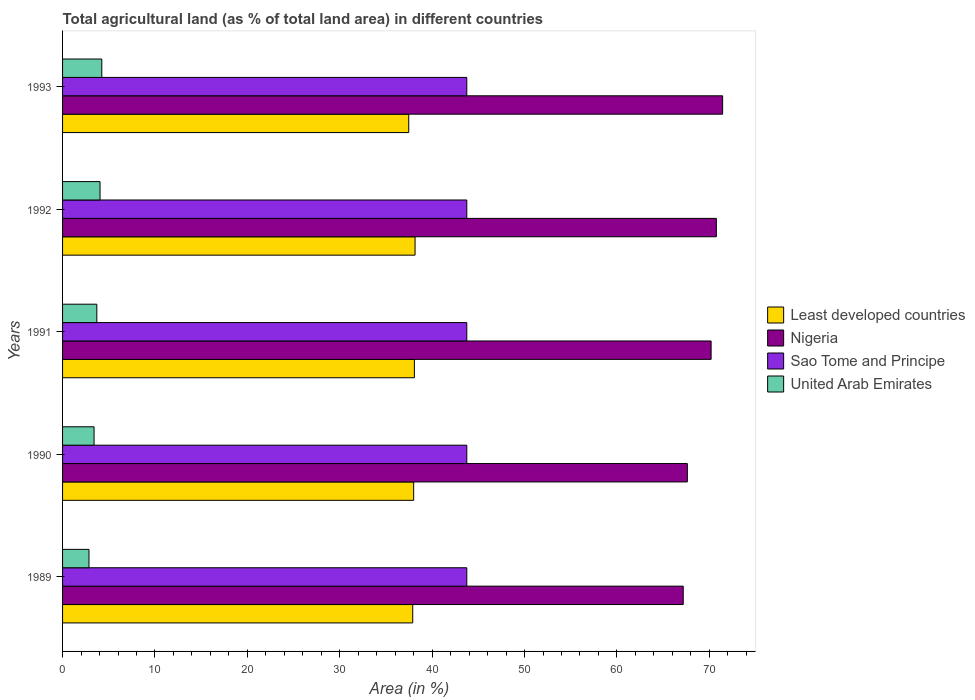Are the number of bars per tick equal to the number of legend labels?
Offer a very short reply. Yes. Are the number of bars on each tick of the Y-axis equal?
Your answer should be compact. Yes. How many bars are there on the 3rd tick from the top?
Offer a terse response. 4. How many bars are there on the 5th tick from the bottom?
Your answer should be compact. 4. What is the percentage of agricultural land in United Arab Emirates in 1991?
Make the answer very short. 3.71. Across all years, what is the maximum percentage of agricultural land in Least developed countries?
Provide a short and direct response. 38.15. Across all years, what is the minimum percentage of agricultural land in Least developed countries?
Offer a very short reply. 37.47. In which year was the percentage of agricultural land in United Arab Emirates minimum?
Make the answer very short. 1989. What is the total percentage of agricultural land in United Arab Emirates in the graph?
Offer a very short reply. 18.28. What is the difference between the percentage of agricultural land in Nigeria in 1990 and that in 1993?
Offer a terse response. -3.82. What is the difference between the percentage of agricultural land in Least developed countries in 1990 and the percentage of agricultural land in Nigeria in 1989?
Give a very brief answer. -29.18. What is the average percentage of agricultural land in Least developed countries per year?
Keep it short and to the point. 37.92. In the year 1991, what is the difference between the percentage of agricultural land in Sao Tome and Principe and percentage of agricultural land in Nigeria?
Offer a very short reply. -26.44. What is the ratio of the percentage of agricultural land in Sao Tome and Principe in 1989 to that in 1991?
Ensure brevity in your answer.  1. Is the percentage of agricultural land in Least developed countries in 1990 less than that in 1991?
Your response must be concise. Yes. Is the difference between the percentage of agricultural land in Sao Tome and Principe in 1990 and 1993 greater than the difference between the percentage of agricultural land in Nigeria in 1990 and 1993?
Provide a short and direct response. Yes. What is the difference between the highest and the second highest percentage of agricultural land in United Arab Emirates?
Ensure brevity in your answer.  0.19. What is the difference between the highest and the lowest percentage of agricultural land in United Arab Emirates?
Ensure brevity in your answer.  1.39. Is it the case that in every year, the sum of the percentage of agricultural land in Nigeria and percentage of agricultural land in Least developed countries is greater than the sum of percentage of agricultural land in United Arab Emirates and percentage of agricultural land in Sao Tome and Principe?
Make the answer very short. No. What does the 4th bar from the top in 1989 represents?
Offer a terse response. Least developed countries. What does the 1st bar from the bottom in 1992 represents?
Offer a terse response. Least developed countries. Is it the case that in every year, the sum of the percentage of agricultural land in Sao Tome and Principe and percentage of agricultural land in Least developed countries is greater than the percentage of agricultural land in Nigeria?
Provide a succinct answer. Yes. Are all the bars in the graph horizontal?
Provide a succinct answer. Yes. How many years are there in the graph?
Make the answer very short. 5. What is the difference between two consecutive major ticks on the X-axis?
Your response must be concise. 10. Does the graph contain any zero values?
Ensure brevity in your answer.  No. Where does the legend appear in the graph?
Your answer should be compact. Center right. How many legend labels are there?
Give a very brief answer. 4. What is the title of the graph?
Offer a terse response. Total agricultural land (as % of total land area) in different countries. What is the label or title of the X-axis?
Offer a very short reply. Area (in %). What is the label or title of the Y-axis?
Keep it short and to the point. Years. What is the Area (in %) of Least developed countries in 1989?
Your answer should be compact. 37.9. What is the Area (in %) of Nigeria in 1989?
Your answer should be very brief. 67.18. What is the Area (in %) in Sao Tome and Principe in 1989?
Ensure brevity in your answer.  43.75. What is the Area (in %) in United Arab Emirates in 1989?
Make the answer very short. 2.86. What is the Area (in %) of Least developed countries in 1990?
Make the answer very short. 38. What is the Area (in %) of Nigeria in 1990?
Your answer should be very brief. 67.62. What is the Area (in %) of Sao Tome and Principe in 1990?
Keep it short and to the point. 43.75. What is the Area (in %) of United Arab Emirates in 1990?
Ensure brevity in your answer.  3.41. What is the Area (in %) in Least developed countries in 1991?
Your answer should be compact. 38.08. What is the Area (in %) of Nigeria in 1991?
Your answer should be compact. 70.19. What is the Area (in %) in Sao Tome and Principe in 1991?
Provide a short and direct response. 43.75. What is the Area (in %) of United Arab Emirates in 1991?
Offer a terse response. 3.71. What is the Area (in %) in Least developed countries in 1992?
Ensure brevity in your answer.  38.15. What is the Area (in %) of Nigeria in 1992?
Give a very brief answer. 70.76. What is the Area (in %) in Sao Tome and Principe in 1992?
Give a very brief answer. 43.75. What is the Area (in %) of United Arab Emirates in 1992?
Your answer should be compact. 4.06. What is the Area (in %) in Least developed countries in 1993?
Offer a terse response. 37.47. What is the Area (in %) of Nigeria in 1993?
Your answer should be compact. 71.44. What is the Area (in %) of Sao Tome and Principe in 1993?
Your answer should be compact. 43.75. What is the Area (in %) of United Arab Emirates in 1993?
Provide a short and direct response. 4.25. Across all years, what is the maximum Area (in %) of Least developed countries?
Provide a succinct answer. 38.15. Across all years, what is the maximum Area (in %) of Nigeria?
Offer a terse response. 71.44. Across all years, what is the maximum Area (in %) in Sao Tome and Principe?
Ensure brevity in your answer.  43.75. Across all years, what is the maximum Area (in %) of United Arab Emirates?
Ensure brevity in your answer.  4.25. Across all years, what is the minimum Area (in %) in Least developed countries?
Give a very brief answer. 37.47. Across all years, what is the minimum Area (in %) of Nigeria?
Provide a succinct answer. 67.18. Across all years, what is the minimum Area (in %) in Sao Tome and Principe?
Offer a terse response. 43.75. Across all years, what is the minimum Area (in %) of United Arab Emirates?
Make the answer very short. 2.86. What is the total Area (in %) in Least developed countries in the graph?
Give a very brief answer. 189.59. What is the total Area (in %) of Nigeria in the graph?
Give a very brief answer. 347.19. What is the total Area (in %) in Sao Tome and Principe in the graph?
Ensure brevity in your answer.  218.75. What is the total Area (in %) of United Arab Emirates in the graph?
Make the answer very short. 18.28. What is the difference between the Area (in %) in Least developed countries in 1989 and that in 1990?
Offer a terse response. -0.1. What is the difference between the Area (in %) in Nigeria in 1989 and that in 1990?
Keep it short and to the point. -0.44. What is the difference between the Area (in %) of Sao Tome and Principe in 1989 and that in 1990?
Keep it short and to the point. 0. What is the difference between the Area (in %) in United Arab Emirates in 1989 and that in 1990?
Keep it short and to the point. -0.55. What is the difference between the Area (in %) of Least developed countries in 1989 and that in 1991?
Keep it short and to the point. -0.18. What is the difference between the Area (in %) in Nigeria in 1989 and that in 1991?
Give a very brief answer. -3.02. What is the difference between the Area (in %) of Sao Tome and Principe in 1989 and that in 1991?
Your answer should be very brief. 0. What is the difference between the Area (in %) of United Arab Emirates in 1989 and that in 1991?
Offer a terse response. -0.85. What is the difference between the Area (in %) of Least developed countries in 1989 and that in 1992?
Offer a very short reply. -0.25. What is the difference between the Area (in %) in Nigeria in 1989 and that in 1992?
Ensure brevity in your answer.  -3.58. What is the difference between the Area (in %) in United Arab Emirates in 1989 and that in 1992?
Provide a succinct answer. -1.2. What is the difference between the Area (in %) of Least developed countries in 1989 and that in 1993?
Provide a short and direct response. 0.43. What is the difference between the Area (in %) in Nigeria in 1989 and that in 1993?
Ensure brevity in your answer.  -4.26. What is the difference between the Area (in %) of Sao Tome and Principe in 1989 and that in 1993?
Your answer should be very brief. 0. What is the difference between the Area (in %) in United Arab Emirates in 1989 and that in 1993?
Offer a terse response. -1.39. What is the difference between the Area (in %) of Least developed countries in 1990 and that in 1991?
Provide a succinct answer. -0.08. What is the difference between the Area (in %) of Nigeria in 1990 and that in 1991?
Ensure brevity in your answer.  -2.57. What is the difference between the Area (in %) of United Arab Emirates in 1990 and that in 1991?
Make the answer very short. -0.3. What is the difference between the Area (in %) of Least developed countries in 1990 and that in 1992?
Your answer should be compact. -0.15. What is the difference between the Area (in %) of Nigeria in 1990 and that in 1992?
Give a very brief answer. -3.14. What is the difference between the Area (in %) in Sao Tome and Principe in 1990 and that in 1992?
Provide a short and direct response. 0. What is the difference between the Area (in %) of United Arab Emirates in 1990 and that in 1992?
Make the answer very short. -0.65. What is the difference between the Area (in %) in Least developed countries in 1990 and that in 1993?
Ensure brevity in your answer.  0.53. What is the difference between the Area (in %) of Nigeria in 1990 and that in 1993?
Make the answer very short. -3.82. What is the difference between the Area (in %) of United Arab Emirates in 1990 and that in 1993?
Give a very brief answer. -0.84. What is the difference between the Area (in %) in Least developed countries in 1991 and that in 1992?
Keep it short and to the point. -0.07. What is the difference between the Area (in %) of Nigeria in 1991 and that in 1992?
Keep it short and to the point. -0.57. What is the difference between the Area (in %) in Sao Tome and Principe in 1991 and that in 1992?
Offer a very short reply. 0. What is the difference between the Area (in %) of United Arab Emirates in 1991 and that in 1992?
Ensure brevity in your answer.  -0.35. What is the difference between the Area (in %) in Least developed countries in 1991 and that in 1993?
Make the answer very short. 0.61. What is the difference between the Area (in %) in Nigeria in 1991 and that in 1993?
Ensure brevity in your answer.  -1.25. What is the difference between the Area (in %) of United Arab Emirates in 1991 and that in 1993?
Provide a succinct answer. -0.54. What is the difference between the Area (in %) in Least developed countries in 1992 and that in 1993?
Provide a succinct answer. 0.68. What is the difference between the Area (in %) of Nigeria in 1992 and that in 1993?
Your response must be concise. -0.68. What is the difference between the Area (in %) in Sao Tome and Principe in 1992 and that in 1993?
Offer a terse response. 0. What is the difference between the Area (in %) in United Arab Emirates in 1992 and that in 1993?
Offer a very short reply. -0.19. What is the difference between the Area (in %) in Least developed countries in 1989 and the Area (in %) in Nigeria in 1990?
Your answer should be very brief. -29.72. What is the difference between the Area (in %) in Least developed countries in 1989 and the Area (in %) in Sao Tome and Principe in 1990?
Your answer should be very brief. -5.85. What is the difference between the Area (in %) in Least developed countries in 1989 and the Area (in %) in United Arab Emirates in 1990?
Provide a short and direct response. 34.49. What is the difference between the Area (in %) of Nigeria in 1989 and the Area (in %) of Sao Tome and Principe in 1990?
Keep it short and to the point. 23.43. What is the difference between the Area (in %) of Nigeria in 1989 and the Area (in %) of United Arab Emirates in 1990?
Offer a terse response. 63.77. What is the difference between the Area (in %) in Sao Tome and Principe in 1989 and the Area (in %) in United Arab Emirates in 1990?
Your answer should be compact. 40.34. What is the difference between the Area (in %) of Least developed countries in 1989 and the Area (in %) of Nigeria in 1991?
Your response must be concise. -32.29. What is the difference between the Area (in %) in Least developed countries in 1989 and the Area (in %) in Sao Tome and Principe in 1991?
Offer a terse response. -5.85. What is the difference between the Area (in %) in Least developed countries in 1989 and the Area (in %) in United Arab Emirates in 1991?
Your answer should be very brief. 34.19. What is the difference between the Area (in %) in Nigeria in 1989 and the Area (in %) in Sao Tome and Principe in 1991?
Ensure brevity in your answer.  23.43. What is the difference between the Area (in %) in Nigeria in 1989 and the Area (in %) in United Arab Emirates in 1991?
Provide a short and direct response. 63.47. What is the difference between the Area (in %) in Sao Tome and Principe in 1989 and the Area (in %) in United Arab Emirates in 1991?
Offer a very short reply. 40.04. What is the difference between the Area (in %) of Least developed countries in 1989 and the Area (in %) of Nigeria in 1992?
Offer a very short reply. -32.86. What is the difference between the Area (in %) in Least developed countries in 1989 and the Area (in %) in Sao Tome and Principe in 1992?
Ensure brevity in your answer.  -5.85. What is the difference between the Area (in %) in Least developed countries in 1989 and the Area (in %) in United Arab Emirates in 1992?
Ensure brevity in your answer.  33.84. What is the difference between the Area (in %) of Nigeria in 1989 and the Area (in %) of Sao Tome and Principe in 1992?
Ensure brevity in your answer.  23.43. What is the difference between the Area (in %) of Nigeria in 1989 and the Area (in %) of United Arab Emirates in 1992?
Provide a short and direct response. 63.12. What is the difference between the Area (in %) in Sao Tome and Principe in 1989 and the Area (in %) in United Arab Emirates in 1992?
Provide a short and direct response. 39.7. What is the difference between the Area (in %) in Least developed countries in 1989 and the Area (in %) in Nigeria in 1993?
Offer a terse response. -33.54. What is the difference between the Area (in %) of Least developed countries in 1989 and the Area (in %) of Sao Tome and Principe in 1993?
Your response must be concise. -5.85. What is the difference between the Area (in %) of Least developed countries in 1989 and the Area (in %) of United Arab Emirates in 1993?
Your answer should be compact. 33.65. What is the difference between the Area (in %) of Nigeria in 1989 and the Area (in %) of Sao Tome and Principe in 1993?
Keep it short and to the point. 23.43. What is the difference between the Area (in %) in Nigeria in 1989 and the Area (in %) in United Arab Emirates in 1993?
Your answer should be compact. 62.93. What is the difference between the Area (in %) of Sao Tome and Principe in 1989 and the Area (in %) of United Arab Emirates in 1993?
Your answer should be compact. 39.5. What is the difference between the Area (in %) of Least developed countries in 1990 and the Area (in %) of Nigeria in 1991?
Offer a very short reply. -32.19. What is the difference between the Area (in %) of Least developed countries in 1990 and the Area (in %) of Sao Tome and Principe in 1991?
Ensure brevity in your answer.  -5.75. What is the difference between the Area (in %) of Least developed countries in 1990 and the Area (in %) of United Arab Emirates in 1991?
Offer a terse response. 34.29. What is the difference between the Area (in %) in Nigeria in 1990 and the Area (in %) in Sao Tome and Principe in 1991?
Give a very brief answer. 23.87. What is the difference between the Area (in %) in Nigeria in 1990 and the Area (in %) in United Arab Emirates in 1991?
Ensure brevity in your answer.  63.91. What is the difference between the Area (in %) in Sao Tome and Principe in 1990 and the Area (in %) in United Arab Emirates in 1991?
Provide a short and direct response. 40.04. What is the difference between the Area (in %) in Least developed countries in 1990 and the Area (in %) in Nigeria in 1992?
Your answer should be compact. -32.76. What is the difference between the Area (in %) in Least developed countries in 1990 and the Area (in %) in Sao Tome and Principe in 1992?
Offer a terse response. -5.75. What is the difference between the Area (in %) of Least developed countries in 1990 and the Area (in %) of United Arab Emirates in 1992?
Your response must be concise. 33.94. What is the difference between the Area (in %) of Nigeria in 1990 and the Area (in %) of Sao Tome and Principe in 1992?
Your response must be concise. 23.87. What is the difference between the Area (in %) of Nigeria in 1990 and the Area (in %) of United Arab Emirates in 1992?
Your answer should be compact. 63.56. What is the difference between the Area (in %) of Sao Tome and Principe in 1990 and the Area (in %) of United Arab Emirates in 1992?
Offer a very short reply. 39.7. What is the difference between the Area (in %) in Least developed countries in 1990 and the Area (in %) in Nigeria in 1993?
Offer a terse response. -33.44. What is the difference between the Area (in %) of Least developed countries in 1990 and the Area (in %) of Sao Tome and Principe in 1993?
Provide a succinct answer. -5.75. What is the difference between the Area (in %) of Least developed countries in 1990 and the Area (in %) of United Arab Emirates in 1993?
Your response must be concise. 33.75. What is the difference between the Area (in %) of Nigeria in 1990 and the Area (in %) of Sao Tome and Principe in 1993?
Your answer should be very brief. 23.87. What is the difference between the Area (in %) in Nigeria in 1990 and the Area (in %) in United Arab Emirates in 1993?
Give a very brief answer. 63.37. What is the difference between the Area (in %) of Sao Tome and Principe in 1990 and the Area (in %) of United Arab Emirates in 1993?
Your answer should be compact. 39.5. What is the difference between the Area (in %) of Least developed countries in 1991 and the Area (in %) of Nigeria in 1992?
Your answer should be very brief. -32.68. What is the difference between the Area (in %) of Least developed countries in 1991 and the Area (in %) of Sao Tome and Principe in 1992?
Ensure brevity in your answer.  -5.67. What is the difference between the Area (in %) of Least developed countries in 1991 and the Area (in %) of United Arab Emirates in 1992?
Make the answer very short. 34.02. What is the difference between the Area (in %) in Nigeria in 1991 and the Area (in %) in Sao Tome and Principe in 1992?
Ensure brevity in your answer.  26.44. What is the difference between the Area (in %) of Nigeria in 1991 and the Area (in %) of United Arab Emirates in 1992?
Your response must be concise. 66.14. What is the difference between the Area (in %) in Sao Tome and Principe in 1991 and the Area (in %) in United Arab Emirates in 1992?
Keep it short and to the point. 39.7. What is the difference between the Area (in %) of Least developed countries in 1991 and the Area (in %) of Nigeria in 1993?
Your response must be concise. -33.36. What is the difference between the Area (in %) of Least developed countries in 1991 and the Area (in %) of Sao Tome and Principe in 1993?
Offer a very short reply. -5.67. What is the difference between the Area (in %) in Least developed countries in 1991 and the Area (in %) in United Arab Emirates in 1993?
Offer a very short reply. 33.83. What is the difference between the Area (in %) in Nigeria in 1991 and the Area (in %) in Sao Tome and Principe in 1993?
Your answer should be very brief. 26.44. What is the difference between the Area (in %) of Nigeria in 1991 and the Area (in %) of United Arab Emirates in 1993?
Provide a succinct answer. 65.95. What is the difference between the Area (in %) of Sao Tome and Principe in 1991 and the Area (in %) of United Arab Emirates in 1993?
Give a very brief answer. 39.5. What is the difference between the Area (in %) in Least developed countries in 1992 and the Area (in %) in Nigeria in 1993?
Give a very brief answer. -33.29. What is the difference between the Area (in %) of Least developed countries in 1992 and the Area (in %) of Sao Tome and Principe in 1993?
Your answer should be compact. -5.6. What is the difference between the Area (in %) in Least developed countries in 1992 and the Area (in %) in United Arab Emirates in 1993?
Your answer should be compact. 33.9. What is the difference between the Area (in %) of Nigeria in 1992 and the Area (in %) of Sao Tome and Principe in 1993?
Give a very brief answer. 27.01. What is the difference between the Area (in %) in Nigeria in 1992 and the Area (in %) in United Arab Emirates in 1993?
Your response must be concise. 66.51. What is the difference between the Area (in %) of Sao Tome and Principe in 1992 and the Area (in %) of United Arab Emirates in 1993?
Offer a very short reply. 39.5. What is the average Area (in %) of Least developed countries per year?
Keep it short and to the point. 37.92. What is the average Area (in %) of Nigeria per year?
Provide a short and direct response. 69.44. What is the average Area (in %) of Sao Tome and Principe per year?
Offer a very short reply. 43.75. What is the average Area (in %) in United Arab Emirates per year?
Give a very brief answer. 3.66. In the year 1989, what is the difference between the Area (in %) in Least developed countries and Area (in %) in Nigeria?
Provide a succinct answer. -29.28. In the year 1989, what is the difference between the Area (in %) of Least developed countries and Area (in %) of Sao Tome and Principe?
Give a very brief answer. -5.85. In the year 1989, what is the difference between the Area (in %) of Least developed countries and Area (in %) of United Arab Emirates?
Provide a short and direct response. 35.04. In the year 1989, what is the difference between the Area (in %) of Nigeria and Area (in %) of Sao Tome and Principe?
Your answer should be very brief. 23.43. In the year 1989, what is the difference between the Area (in %) in Nigeria and Area (in %) in United Arab Emirates?
Offer a terse response. 64.32. In the year 1989, what is the difference between the Area (in %) in Sao Tome and Principe and Area (in %) in United Arab Emirates?
Offer a very short reply. 40.89. In the year 1990, what is the difference between the Area (in %) of Least developed countries and Area (in %) of Nigeria?
Your response must be concise. -29.62. In the year 1990, what is the difference between the Area (in %) in Least developed countries and Area (in %) in Sao Tome and Principe?
Provide a short and direct response. -5.75. In the year 1990, what is the difference between the Area (in %) in Least developed countries and Area (in %) in United Arab Emirates?
Your answer should be compact. 34.59. In the year 1990, what is the difference between the Area (in %) of Nigeria and Area (in %) of Sao Tome and Principe?
Your answer should be compact. 23.87. In the year 1990, what is the difference between the Area (in %) in Nigeria and Area (in %) in United Arab Emirates?
Offer a very short reply. 64.21. In the year 1990, what is the difference between the Area (in %) of Sao Tome and Principe and Area (in %) of United Arab Emirates?
Make the answer very short. 40.34. In the year 1991, what is the difference between the Area (in %) of Least developed countries and Area (in %) of Nigeria?
Make the answer very short. -32.11. In the year 1991, what is the difference between the Area (in %) of Least developed countries and Area (in %) of Sao Tome and Principe?
Give a very brief answer. -5.67. In the year 1991, what is the difference between the Area (in %) of Least developed countries and Area (in %) of United Arab Emirates?
Offer a very short reply. 34.37. In the year 1991, what is the difference between the Area (in %) in Nigeria and Area (in %) in Sao Tome and Principe?
Ensure brevity in your answer.  26.44. In the year 1991, what is the difference between the Area (in %) of Nigeria and Area (in %) of United Arab Emirates?
Your answer should be compact. 66.48. In the year 1991, what is the difference between the Area (in %) of Sao Tome and Principe and Area (in %) of United Arab Emirates?
Your answer should be very brief. 40.04. In the year 1992, what is the difference between the Area (in %) of Least developed countries and Area (in %) of Nigeria?
Your response must be concise. -32.61. In the year 1992, what is the difference between the Area (in %) in Least developed countries and Area (in %) in Sao Tome and Principe?
Offer a terse response. -5.6. In the year 1992, what is the difference between the Area (in %) of Least developed countries and Area (in %) of United Arab Emirates?
Your response must be concise. 34.1. In the year 1992, what is the difference between the Area (in %) of Nigeria and Area (in %) of Sao Tome and Principe?
Keep it short and to the point. 27.01. In the year 1992, what is the difference between the Area (in %) in Nigeria and Area (in %) in United Arab Emirates?
Offer a very short reply. 66.71. In the year 1992, what is the difference between the Area (in %) in Sao Tome and Principe and Area (in %) in United Arab Emirates?
Ensure brevity in your answer.  39.7. In the year 1993, what is the difference between the Area (in %) in Least developed countries and Area (in %) in Nigeria?
Offer a terse response. -33.97. In the year 1993, what is the difference between the Area (in %) in Least developed countries and Area (in %) in Sao Tome and Principe?
Ensure brevity in your answer.  -6.28. In the year 1993, what is the difference between the Area (in %) in Least developed countries and Area (in %) in United Arab Emirates?
Make the answer very short. 33.22. In the year 1993, what is the difference between the Area (in %) in Nigeria and Area (in %) in Sao Tome and Principe?
Ensure brevity in your answer.  27.69. In the year 1993, what is the difference between the Area (in %) of Nigeria and Area (in %) of United Arab Emirates?
Provide a short and direct response. 67.19. In the year 1993, what is the difference between the Area (in %) of Sao Tome and Principe and Area (in %) of United Arab Emirates?
Make the answer very short. 39.5. What is the ratio of the Area (in %) of Least developed countries in 1989 to that in 1990?
Provide a succinct answer. 1. What is the ratio of the Area (in %) in United Arab Emirates in 1989 to that in 1990?
Your answer should be very brief. 0.84. What is the ratio of the Area (in %) in United Arab Emirates in 1989 to that in 1991?
Your response must be concise. 0.77. What is the ratio of the Area (in %) of Least developed countries in 1989 to that in 1992?
Provide a succinct answer. 0.99. What is the ratio of the Area (in %) in Nigeria in 1989 to that in 1992?
Provide a short and direct response. 0.95. What is the ratio of the Area (in %) of United Arab Emirates in 1989 to that in 1992?
Give a very brief answer. 0.7. What is the ratio of the Area (in %) of Least developed countries in 1989 to that in 1993?
Your answer should be very brief. 1.01. What is the ratio of the Area (in %) in Nigeria in 1989 to that in 1993?
Provide a succinct answer. 0.94. What is the ratio of the Area (in %) of United Arab Emirates in 1989 to that in 1993?
Offer a terse response. 0.67. What is the ratio of the Area (in %) of Nigeria in 1990 to that in 1991?
Give a very brief answer. 0.96. What is the ratio of the Area (in %) of United Arab Emirates in 1990 to that in 1991?
Give a very brief answer. 0.92. What is the ratio of the Area (in %) in Nigeria in 1990 to that in 1992?
Offer a very short reply. 0.96. What is the ratio of the Area (in %) of Sao Tome and Principe in 1990 to that in 1992?
Keep it short and to the point. 1. What is the ratio of the Area (in %) of United Arab Emirates in 1990 to that in 1992?
Provide a short and direct response. 0.84. What is the ratio of the Area (in %) in Least developed countries in 1990 to that in 1993?
Ensure brevity in your answer.  1.01. What is the ratio of the Area (in %) of Nigeria in 1990 to that in 1993?
Your answer should be very brief. 0.95. What is the ratio of the Area (in %) of Sao Tome and Principe in 1990 to that in 1993?
Your response must be concise. 1. What is the ratio of the Area (in %) in United Arab Emirates in 1990 to that in 1993?
Ensure brevity in your answer.  0.8. What is the ratio of the Area (in %) in United Arab Emirates in 1991 to that in 1992?
Your answer should be compact. 0.91. What is the ratio of the Area (in %) in Least developed countries in 1991 to that in 1993?
Keep it short and to the point. 1.02. What is the ratio of the Area (in %) of Nigeria in 1991 to that in 1993?
Your answer should be very brief. 0.98. What is the ratio of the Area (in %) of Sao Tome and Principe in 1991 to that in 1993?
Provide a short and direct response. 1. What is the ratio of the Area (in %) in United Arab Emirates in 1991 to that in 1993?
Your response must be concise. 0.87. What is the ratio of the Area (in %) of Least developed countries in 1992 to that in 1993?
Keep it short and to the point. 1.02. What is the ratio of the Area (in %) of Nigeria in 1992 to that in 1993?
Provide a succinct answer. 0.99. What is the ratio of the Area (in %) of United Arab Emirates in 1992 to that in 1993?
Your response must be concise. 0.95. What is the difference between the highest and the second highest Area (in %) in Least developed countries?
Your answer should be compact. 0.07. What is the difference between the highest and the second highest Area (in %) of Nigeria?
Offer a very short reply. 0.68. What is the difference between the highest and the second highest Area (in %) of Sao Tome and Principe?
Give a very brief answer. 0. What is the difference between the highest and the second highest Area (in %) in United Arab Emirates?
Provide a succinct answer. 0.19. What is the difference between the highest and the lowest Area (in %) in Least developed countries?
Your answer should be compact. 0.68. What is the difference between the highest and the lowest Area (in %) of Nigeria?
Offer a terse response. 4.26. What is the difference between the highest and the lowest Area (in %) in Sao Tome and Principe?
Your answer should be compact. 0. What is the difference between the highest and the lowest Area (in %) of United Arab Emirates?
Keep it short and to the point. 1.39. 